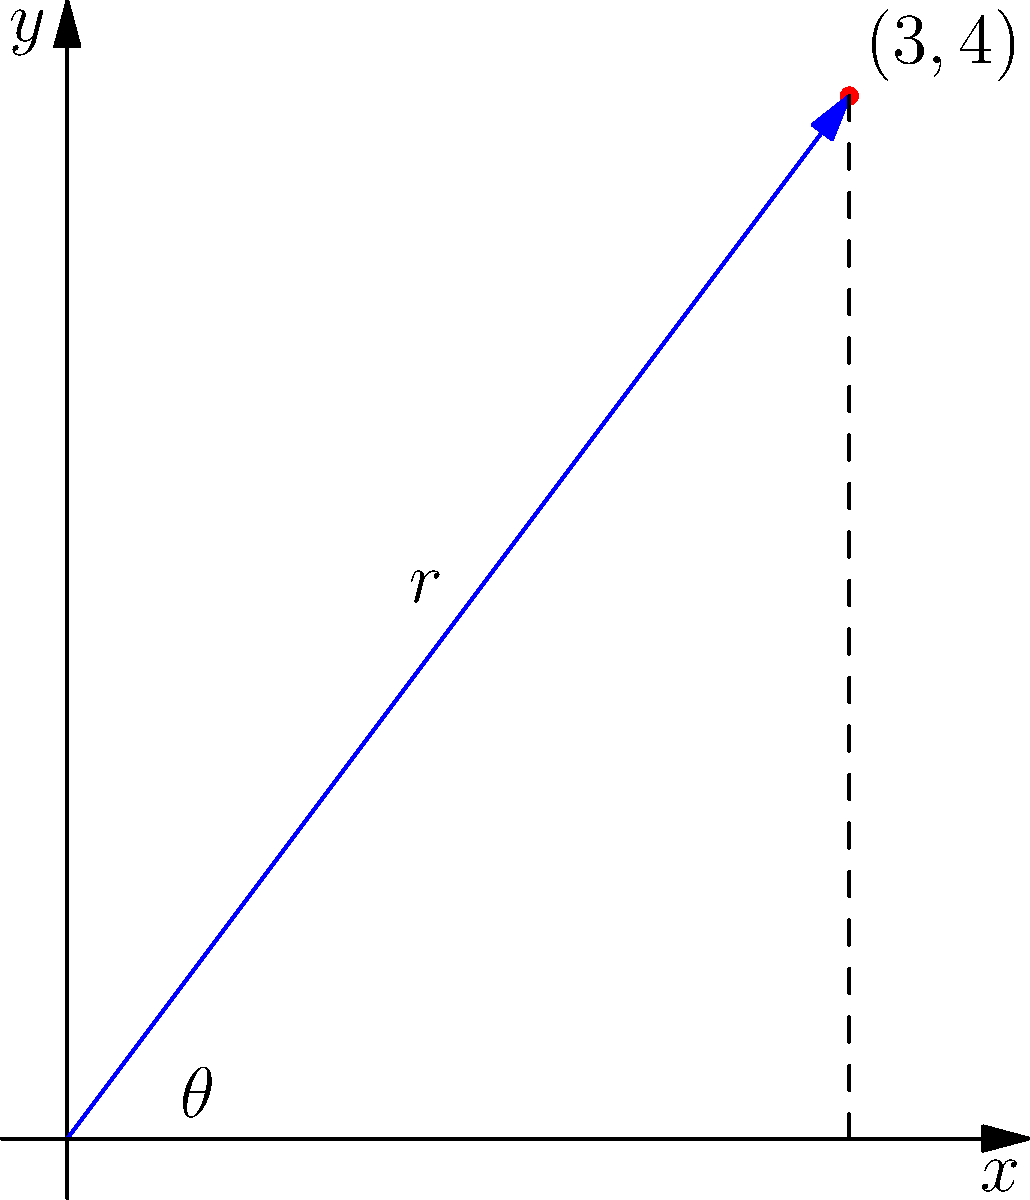As a school principal allocating educational resources, you're plotting the distribution of funds between two programs on a Cartesian plane. The point (3, 4) represents the current allocation. Convert this point to polar coordinates $(r, \theta)$, where $r$ is rounded to two decimal places and $\theta$ is expressed in radians rounded to two decimal places. What are the polar coordinates? To convert Cartesian coordinates $(x, y)$ to polar coordinates $(r, \theta)$, we use the following formulas:

1) $r = \sqrt{x^2 + y^2}$
2) $\theta = \tan^{-1}(\frac{y}{x})$

For the point (3, 4):

1) Calculate $r$:
   $r = \sqrt{3^2 + 4^2} = \sqrt{9 + 16} = \sqrt{25} = 5$

2) Calculate $\theta$:
   $\theta = \tan^{-1}(\frac{4}{3}) \approx 0.9273$ radians

3) Round $r$ to two decimal places:
   $r \approx 5.00$

4) Round $\theta$ to two decimal places:
   $\theta \approx 0.93$ radians

Therefore, the polar coordinates are $(5.00, 0.93)$.
Answer: $(5.00, 0.93)$ 